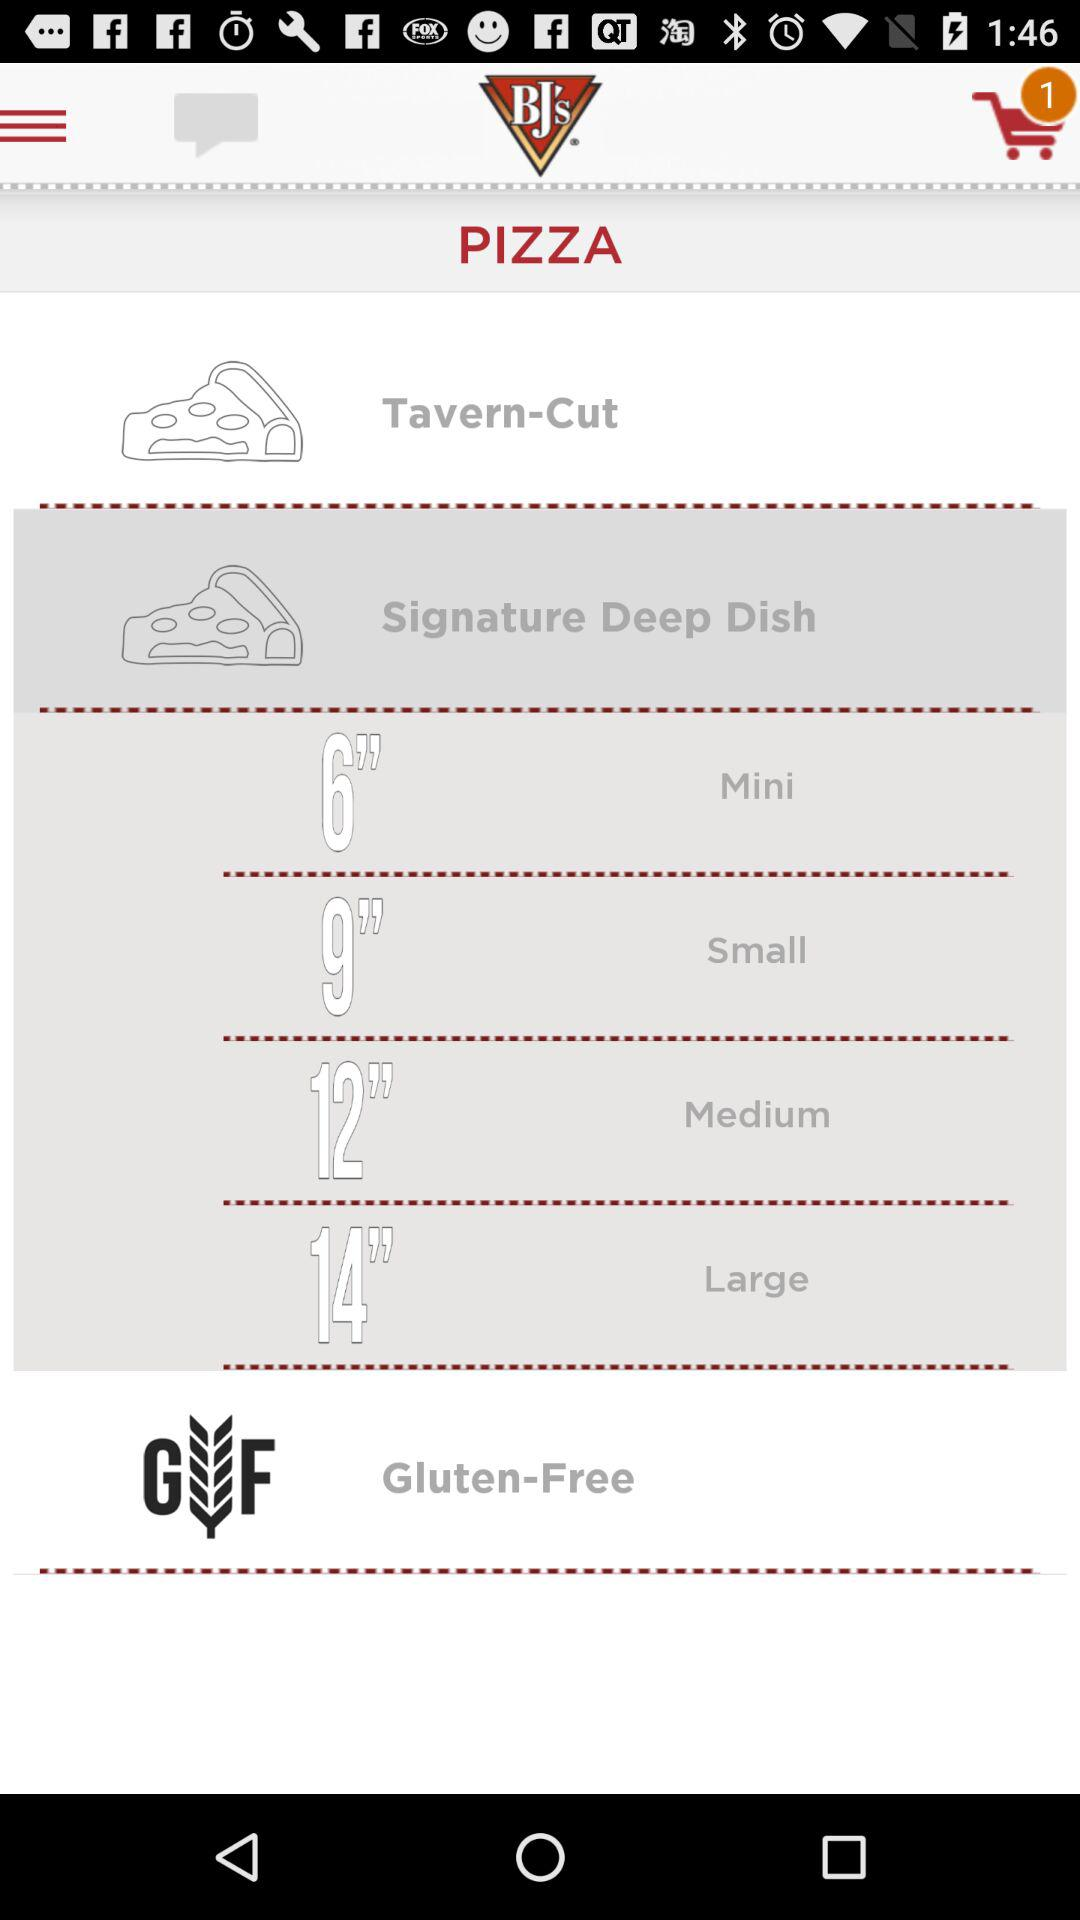How many products are in the cart? There is 1 product in the cart. 